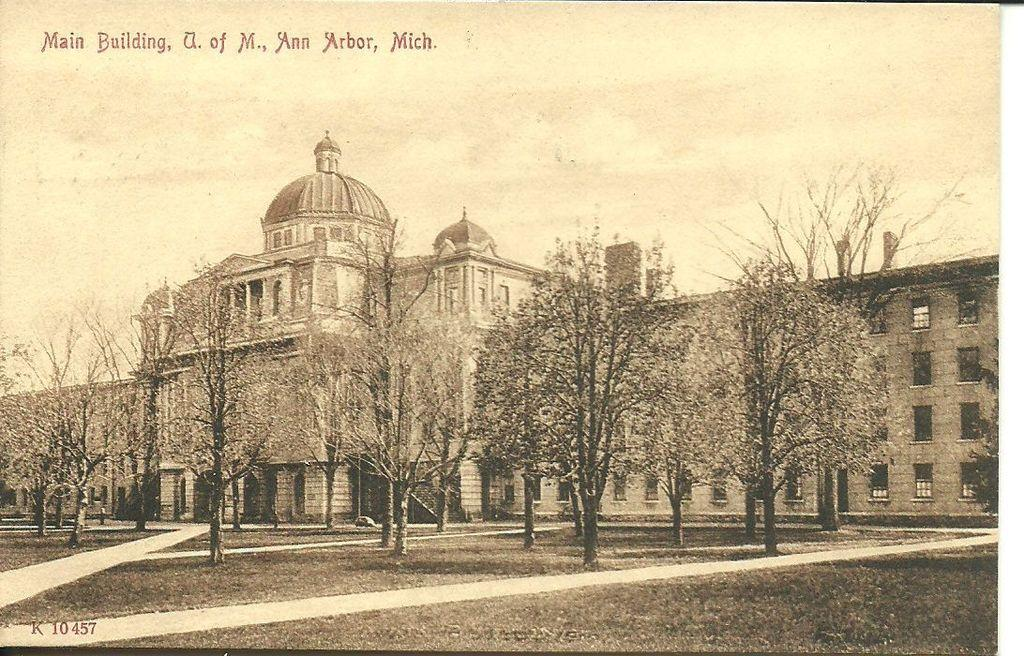What is featured on the poster in the image? There is a poster in the image that contains words, numbers, an image of a building, and trees. What can be seen in the background of the poster? The sky is visible in the background of the poster. What type of scissors can be seen on the roof of the building depicted on the poster? There are no scissors visible on the roof of the building depicted on the poster. 